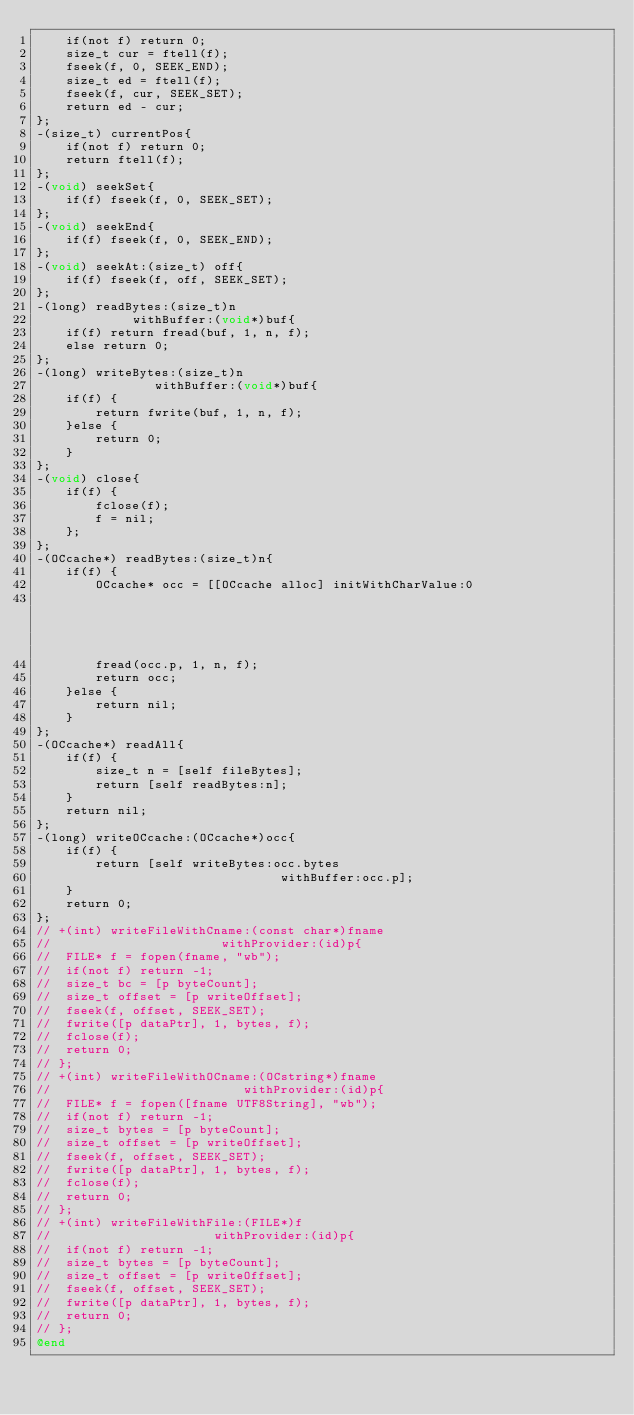Convert code to text. <code><loc_0><loc_0><loc_500><loc_500><_ObjectiveC_>	if(not f) return 0;
	size_t cur = ftell(f);
	fseek(f, 0, SEEK_END);
	size_t ed = ftell(f);
	fseek(f, cur, SEEK_SET);
	return ed - cur;
};
-(size_t) currentPos{
	if(not f) return 0;
	return ftell(f);
};
-(void) seekSet{
	if(f) fseek(f, 0, SEEK_SET);
};
-(void) seekEnd{
	if(f) fseek(f, 0, SEEK_END);
};
-(void) seekAt:(size_t) off{
	if(f) fseek(f, off, SEEK_SET);
};
-(long) readBytes:(size_t)n
			 withBuffer:(void*)buf{
	if(f) return fread(buf, 1, n, f);
	else return 0;
};
-(long) writeBytes:(size_t)n
				withBuffer:(void*)buf{
	if(f) {
		return fwrite(buf, 1, n, f);
	}else {
		return 0;
	}
};
-(void) close{
	if(f) {
		fclose(f);
		f = nil;
	};
};
-(OCcache*) readBytes:(size_t)n{
	if(f) {
		OCcache* occ = [[OCcache alloc] initWithCharValue:0
																								count:n+1];
		fread(occ.p, 1, n, f);
		return occ;
	}else {
		return nil;
	}
};
-(OCcache*) readAll{
	if(f) {
		size_t n = [self fileBytes];
		return [self readBytes:n];
	}
    return nil;
};
-(long) writeOCcache:(OCcache*)occ{
	if(f) {
		return [self writeBytes:occ.bytes
								 withBuffer:occ.p];
	}
	return 0;
};
// +(int) writeFileWithCname:(const char*)fname
// 						 withProvider:(id)p{
// 	FILE* f = fopen(fname, "wb");
// 	if(not f) return -1;
// 	size_t bc = [p byteCount];
// 	size_t offset = [p writeOffset];
// 	fseek(f, offset, SEEK_SET);
// 	fwrite([p dataPtr], 1, bytes, f);
// 	fclose(f);
// 	return 0;
// };
// +(int) writeFileWithOCname:(OCstring*)fname
// 							withProvider:(id)p{
// 	FILE* f = fopen([fname UTF8String], "wb");
// 	if(not f) return -1;
// 	size_t bytes = [p byteCount];
// 	size_t offset = [p writeOffset];
// 	fseek(f, offset, SEEK_SET);
// 	fwrite([p dataPtr], 1, bytes, f);
// 	fclose(f);
// 	return 0;
// };
// +(int) writeFileWithFile:(FILE*)f
// 						withProvider:(id)p{
// 	if(not f) return -1;
// 	size_t bytes = [p byteCount];
// 	size_t offset = [p writeOffset];
// 	fseek(f, offset, SEEK_SET);
// 	fwrite([p dataPtr], 1, bytes, f);
// 	return 0;
// };
@end
</code> 